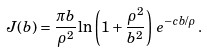<formula> <loc_0><loc_0><loc_500><loc_500>J ( b ) = \frac { \pi b } { \rho ^ { 2 } } \ln \left ( 1 + \frac { \rho ^ { 2 } } { b ^ { 2 } } \right ) \, e ^ { - c b / \rho } \, .</formula> 